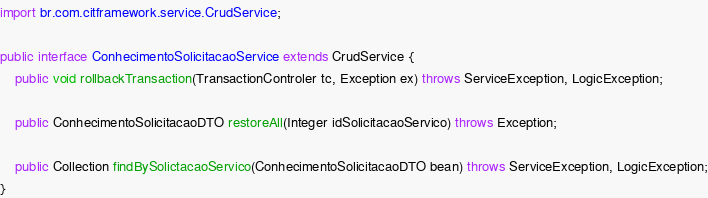<code> <loc_0><loc_0><loc_500><loc_500><_Java_>import br.com.citframework.service.CrudService;

public interface ConhecimentoSolicitacaoService extends CrudService {
	public void rollbackTransaction(TransactionControler tc, Exception ex) throws ServiceException, LogicException;

	public ConhecimentoSolicitacaoDTO restoreAll(Integer idSolicitacaoServico) throws Exception;

	public Collection findBySolictacaoServico(ConhecimentoSolicitacaoDTO bean) throws ServiceException, LogicException;
}</code> 